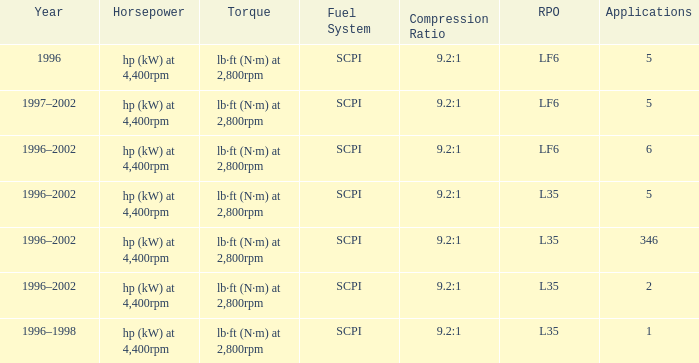What's the compression ratio of the model with L35 RPO and 5 applications? 9.2:1. 